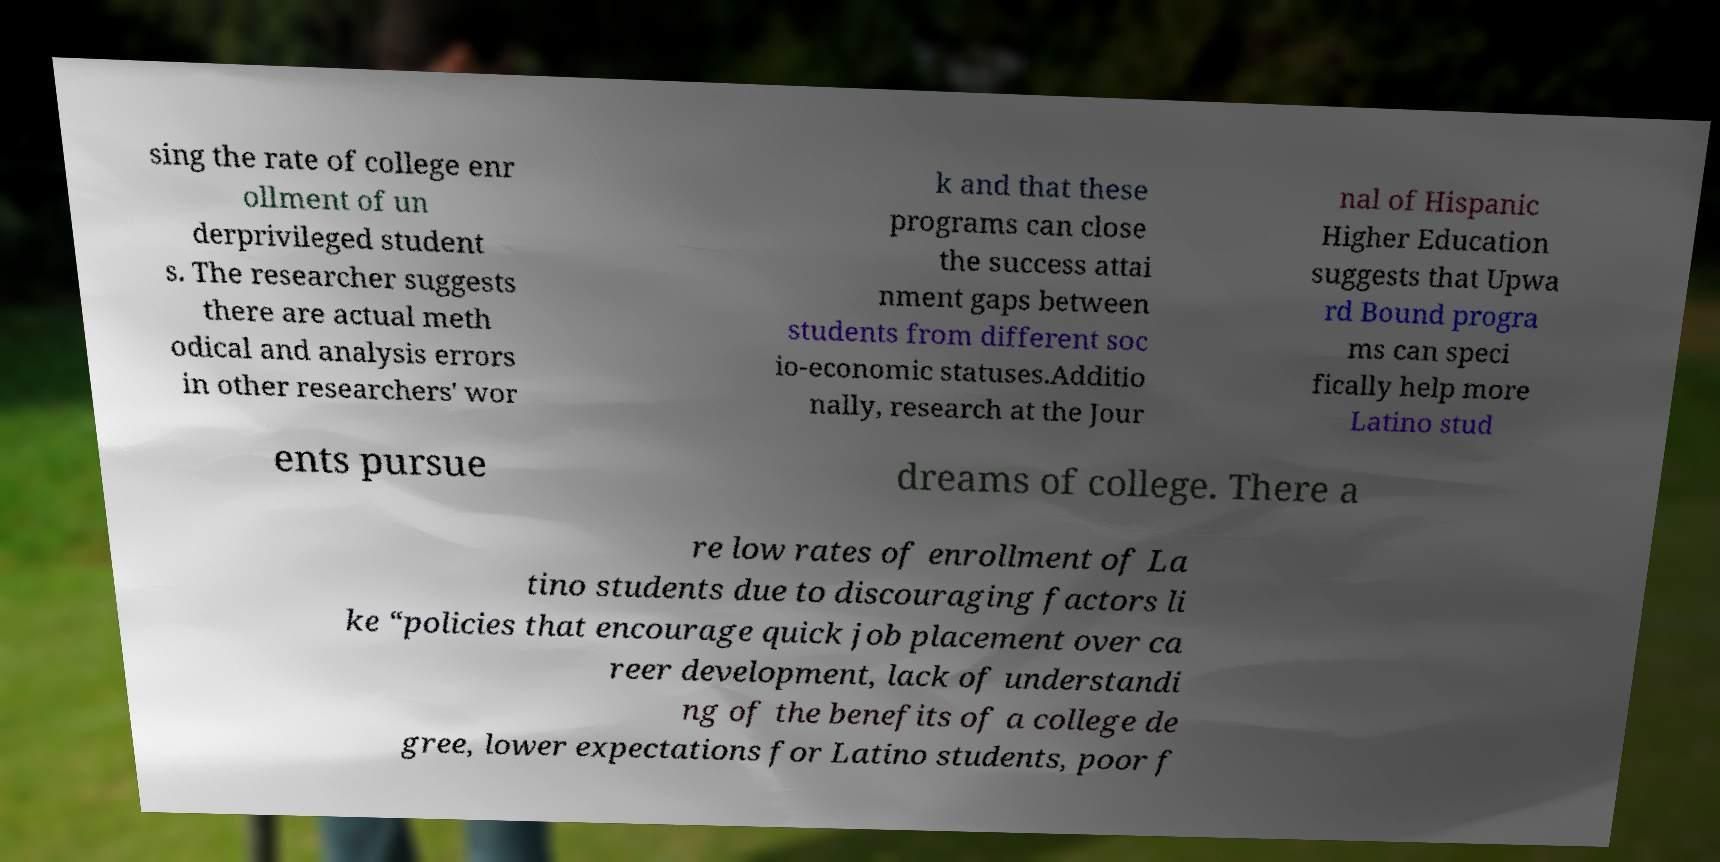Please read and relay the text visible in this image. What does it say? sing the rate of college enr ollment of un derprivileged student s. The researcher suggests there are actual meth odical and analysis errors in other researchers' wor k and that these programs can close the success attai nment gaps between students from different soc io-economic statuses.Additio nally, research at the Jour nal of Hispanic Higher Education suggests that Upwa rd Bound progra ms can speci fically help more Latino stud ents pursue dreams of college. There a re low rates of enrollment of La tino students due to discouraging factors li ke “policies that encourage quick job placement over ca reer development, lack of understandi ng of the benefits of a college de gree, lower expectations for Latino students, poor f 